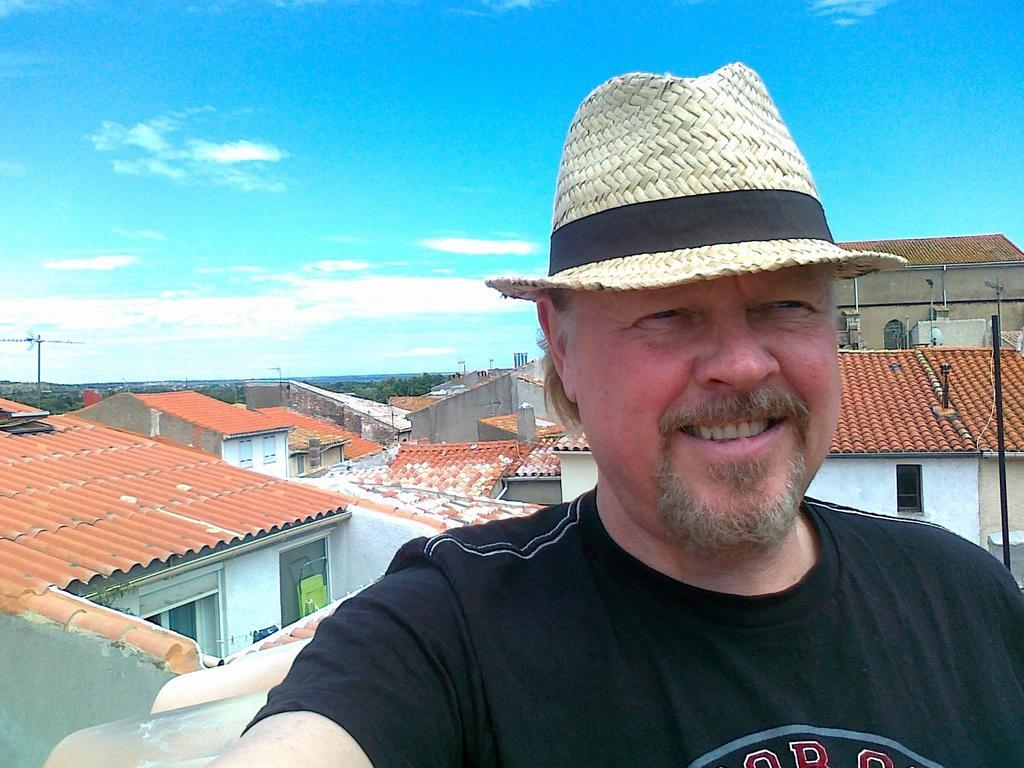In one or two sentences, can you explain what this image depicts? In this picture we can see a man, he wore a cap and he is smiling, behind to him we can find few poles, houses and trees. 